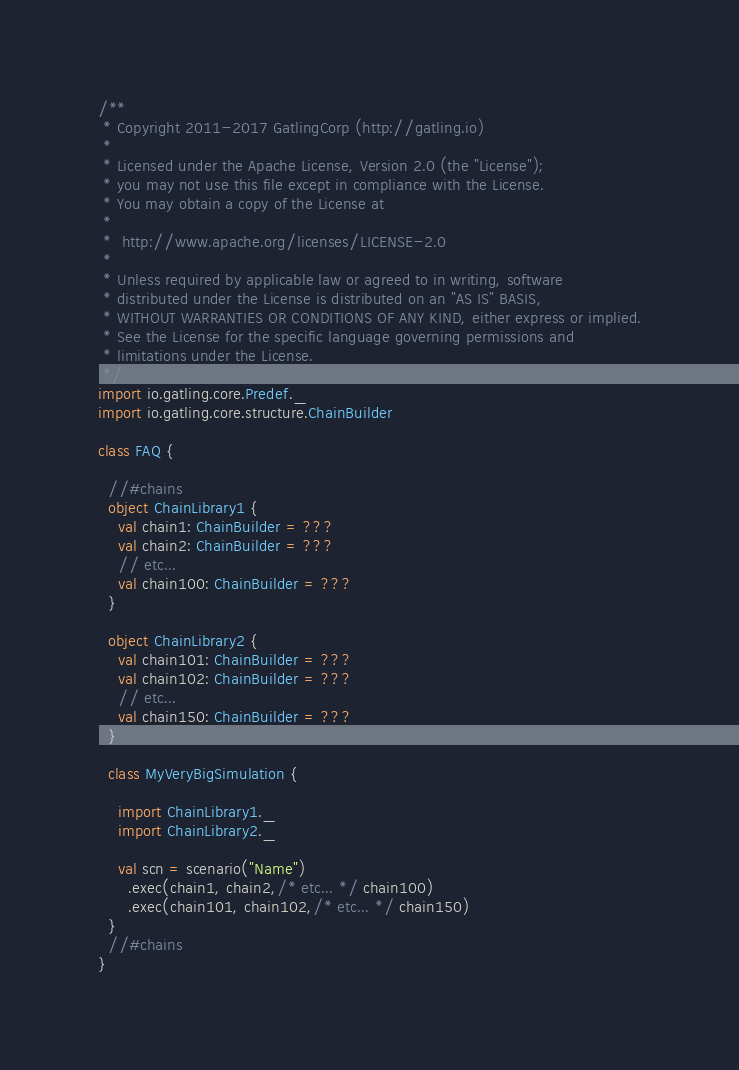<code> <loc_0><loc_0><loc_500><loc_500><_Scala_>/**
 * Copyright 2011-2017 GatlingCorp (http://gatling.io)
 *
 * Licensed under the Apache License, Version 2.0 (the "License");
 * you may not use this file except in compliance with the License.
 * You may obtain a copy of the License at
 *
 *  http://www.apache.org/licenses/LICENSE-2.0
 *
 * Unless required by applicable law or agreed to in writing, software
 * distributed under the License is distributed on an "AS IS" BASIS,
 * WITHOUT WARRANTIES OR CONDITIONS OF ANY KIND, either express or implied.
 * See the License for the specific language governing permissions and
 * limitations under the License.
 */
import io.gatling.core.Predef._
import io.gatling.core.structure.ChainBuilder

class FAQ {

  //#chains
  object ChainLibrary1 {
    val chain1: ChainBuilder = ???
    val chain2: ChainBuilder = ???
    // etc...
    val chain100: ChainBuilder = ???
  }

  object ChainLibrary2 {
    val chain101: ChainBuilder = ???
    val chain102: ChainBuilder = ???
    // etc...
    val chain150: ChainBuilder = ???
  }

  class MyVeryBigSimulation {

    import ChainLibrary1._
    import ChainLibrary2._

    val scn = scenario("Name")
      .exec(chain1, chain2,/* etc... */ chain100)
      .exec(chain101, chain102,/* etc... */ chain150)
  }
  //#chains
}
</code> 